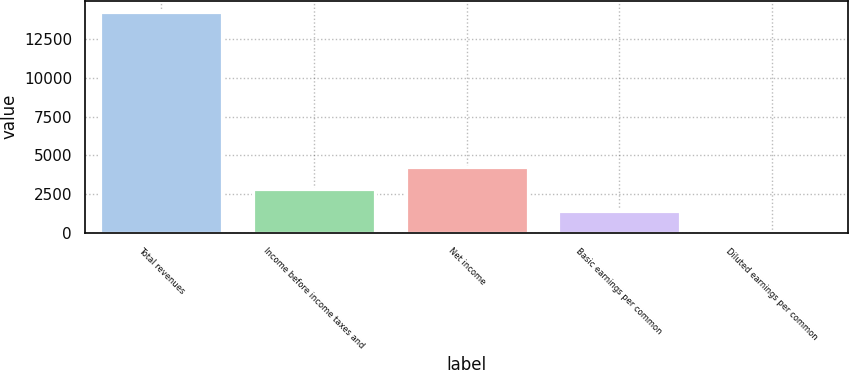<chart> <loc_0><loc_0><loc_500><loc_500><bar_chart><fcel>Total revenues<fcel>Income before income taxes and<fcel>Net income<fcel>Basic earnings per common<fcel>Diluted earnings per common<nl><fcel>14259<fcel>2852.91<fcel>4278.67<fcel>1427.15<fcel>1.39<nl></chart> 